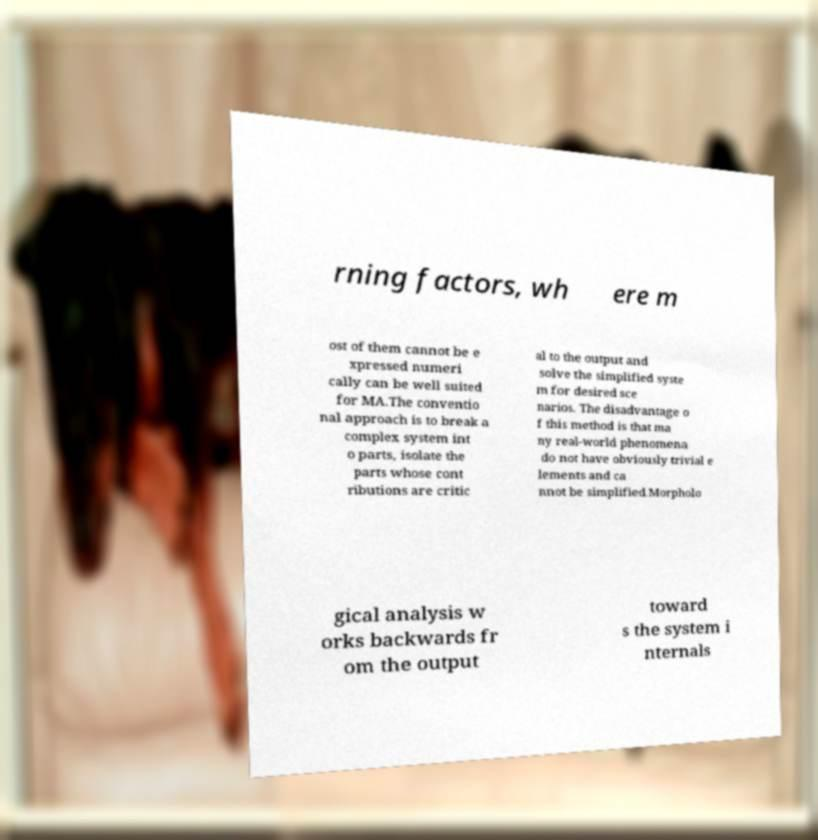Please identify and transcribe the text found in this image. rning factors, wh ere m ost of them cannot be e xpressed numeri cally can be well suited for MA.The conventio nal approach is to break a complex system int o parts, isolate the parts whose cont ributions are critic al to the output and solve the simplified syste m for desired sce narios. The disadvantage o f this method is that ma ny real-world phenomena do not have obviously trivial e lements and ca nnot be simplified.Morpholo gical analysis w orks backwards fr om the output toward s the system i nternals 